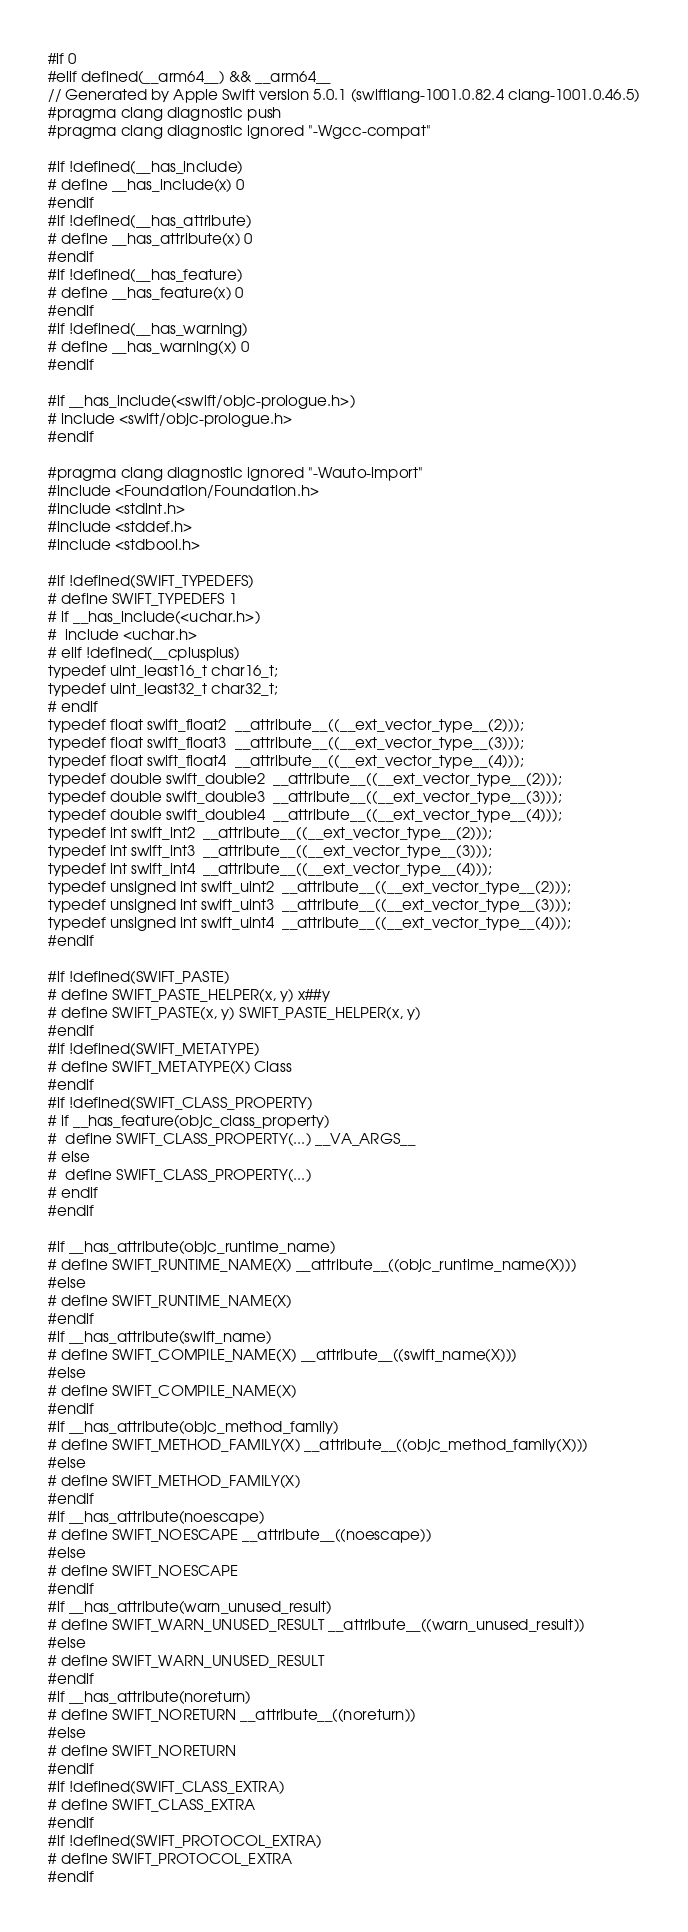Convert code to text. <code><loc_0><loc_0><loc_500><loc_500><_C_>#if 0
#elif defined(__arm64__) && __arm64__
// Generated by Apple Swift version 5.0.1 (swiftlang-1001.0.82.4 clang-1001.0.46.5)
#pragma clang diagnostic push
#pragma clang diagnostic ignored "-Wgcc-compat"

#if !defined(__has_include)
# define __has_include(x) 0
#endif
#if !defined(__has_attribute)
# define __has_attribute(x) 0
#endif
#if !defined(__has_feature)
# define __has_feature(x) 0
#endif
#if !defined(__has_warning)
# define __has_warning(x) 0
#endif

#if __has_include(<swift/objc-prologue.h>)
# include <swift/objc-prologue.h>
#endif

#pragma clang diagnostic ignored "-Wauto-import"
#include <Foundation/Foundation.h>
#include <stdint.h>
#include <stddef.h>
#include <stdbool.h>

#if !defined(SWIFT_TYPEDEFS)
# define SWIFT_TYPEDEFS 1
# if __has_include(<uchar.h>)
#  include <uchar.h>
# elif !defined(__cplusplus)
typedef uint_least16_t char16_t;
typedef uint_least32_t char32_t;
# endif
typedef float swift_float2  __attribute__((__ext_vector_type__(2)));
typedef float swift_float3  __attribute__((__ext_vector_type__(3)));
typedef float swift_float4  __attribute__((__ext_vector_type__(4)));
typedef double swift_double2  __attribute__((__ext_vector_type__(2)));
typedef double swift_double3  __attribute__((__ext_vector_type__(3)));
typedef double swift_double4  __attribute__((__ext_vector_type__(4)));
typedef int swift_int2  __attribute__((__ext_vector_type__(2)));
typedef int swift_int3  __attribute__((__ext_vector_type__(3)));
typedef int swift_int4  __attribute__((__ext_vector_type__(4)));
typedef unsigned int swift_uint2  __attribute__((__ext_vector_type__(2)));
typedef unsigned int swift_uint3  __attribute__((__ext_vector_type__(3)));
typedef unsigned int swift_uint4  __attribute__((__ext_vector_type__(4)));
#endif

#if !defined(SWIFT_PASTE)
# define SWIFT_PASTE_HELPER(x, y) x##y
# define SWIFT_PASTE(x, y) SWIFT_PASTE_HELPER(x, y)
#endif
#if !defined(SWIFT_METATYPE)
# define SWIFT_METATYPE(X) Class
#endif
#if !defined(SWIFT_CLASS_PROPERTY)
# if __has_feature(objc_class_property)
#  define SWIFT_CLASS_PROPERTY(...) __VA_ARGS__
# else
#  define SWIFT_CLASS_PROPERTY(...)
# endif
#endif

#if __has_attribute(objc_runtime_name)
# define SWIFT_RUNTIME_NAME(X) __attribute__((objc_runtime_name(X)))
#else
# define SWIFT_RUNTIME_NAME(X)
#endif
#if __has_attribute(swift_name)
# define SWIFT_COMPILE_NAME(X) __attribute__((swift_name(X)))
#else
# define SWIFT_COMPILE_NAME(X)
#endif
#if __has_attribute(objc_method_family)
# define SWIFT_METHOD_FAMILY(X) __attribute__((objc_method_family(X)))
#else
# define SWIFT_METHOD_FAMILY(X)
#endif
#if __has_attribute(noescape)
# define SWIFT_NOESCAPE __attribute__((noescape))
#else
# define SWIFT_NOESCAPE
#endif
#if __has_attribute(warn_unused_result)
# define SWIFT_WARN_UNUSED_RESULT __attribute__((warn_unused_result))
#else
# define SWIFT_WARN_UNUSED_RESULT
#endif
#if __has_attribute(noreturn)
# define SWIFT_NORETURN __attribute__((noreturn))
#else
# define SWIFT_NORETURN
#endif
#if !defined(SWIFT_CLASS_EXTRA)
# define SWIFT_CLASS_EXTRA
#endif
#if !defined(SWIFT_PROTOCOL_EXTRA)
# define SWIFT_PROTOCOL_EXTRA
#endif</code> 